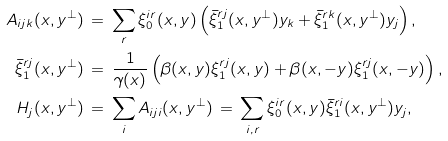Convert formula to latex. <formula><loc_0><loc_0><loc_500><loc_500>A _ { i j k } ( x , y ^ { \perp } ) \, & = \, \sum _ { r } \xi _ { 0 } ^ { i r } ( x , y ) \left ( \bar { \xi } _ { 1 } ^ { r j } ( x , y ^ { \perp } ) y _ { k } + \bar { \xi } _ { 1 } ^ { r k } ( x , y ^ { \perp } ) y _ { j } \right ) , \\ \bar { \xi } _ { 1 } ^ { r j } ( x , y ^ { \perp } ) \, & = \, \frac { 1 } { \gamma ( x ) } \left ( \beta ( x , y ) \xi _ { 1 } ^ { r j } ( x , y ) + \beta ( x , - y ) \xi _ { 1 } ^ { r j } ( x , - y ) \right ) , \\ H _ { j } ( x , y ^ { \perp } ) \, & = \, \sum _ { i } A _ { i j i } ( x , y ^ { \perp } ) \, = \, \sum _ { i , r } \xi _ { 0 } ^ { i r } ( x , y ) \bar { \xi } _ { 1 } ^ { r i } ( x , y ^ { \perp } ) y _ { j } ,</formula> 